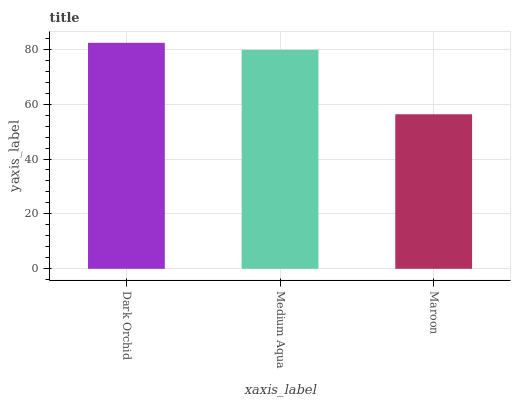Is Maroon the minimum?
Answer yes or no. Yes. Is Dark Orchid the maximum?
Answer yes or no. Yes. Is Medium Aqua the minimum?
Answer yes or no. No. Is Medium Aqua the maximum?
Answer yes or no. No. Is Dark Orchid greater than Medium Aqua?
Answer yes or no. Yes. Is Medium Aqua less than Dark Orchid?
Answer yes or no. Yes. Is Medium Aqua greater than Dark Orchid?
Answer yes or no. No. Is Dark Orchid less than Medium Aqua?
Answer yes or no. No. Is Medium Aqua the high median?
Answer yes or no. Yes. Is Medium Aqua the low median?
Answer yes or no. Yes. Is Dark Orchid the high median?
Answer yes or no. No. Is Maroon the low median?
Answer yes or no. No. 